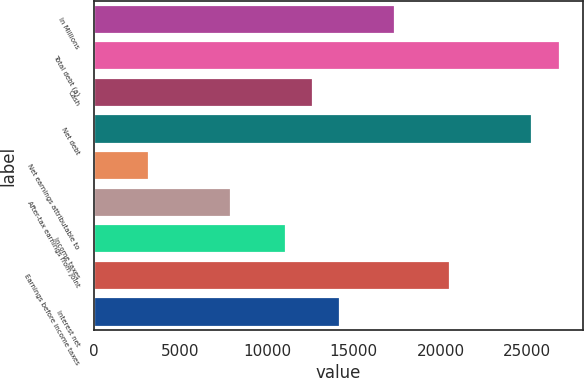Convert chart. <chart><loc_0><loc_0><loc_500><loc_500><bar_chart><fcel>In Millions<fcel>Total debt (a)<fcel>Cash<fcel>Net debt<fcel>Net earnings attributable to<fcel>After-tax earnings from joint<fcel>Income taxes<fcel>Earnings before income taxes<fcel>Interest net<nl><fcel>17400<fcel>26888.7<fcel>12655.7<fcel>25307.2<fcel>3167.08<fcel>7911.4<fcel>11074.3<fcel>20562.9<fcel>14237.2<nl></chart> 